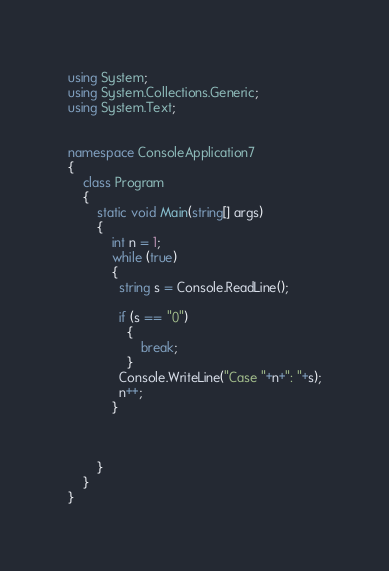Convert code to text. <code><loc_0><loc_0><loc_500><loc_500><_C#_>using System;
using System.Collections.Generic;
using System.Text;


namespace ConsoleApplication7
{
    class Program
    {
        static void Main(string[] args)
        {
            int n = 1;
            while (true)
            {
              string s = Console.ReadLine();

              if (s == "0")
                {
                    break;
                }
              Console.WriteLine("Case "+n+": "+s);
              n++;
            }

          

        }
    }
}</code> 